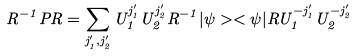Convert formula to latex. <formula><loc_0><loc_0><loc_500><loc_500>R ^ { - 1 } P R = \sum _ { j ^ { \prime } _ { 1 } , j ^ { \prime } _ { 2 } } U _ { 1 } ^ { j ^ { \prime } _ { 1 } } U _ { 2 } ^ { j ^ { \prime } _ { 2 } } R ^ { - 1 } | \psi > < \psi | R U _ { 1 } ^ { - j ^ { \prime } _ { 1 } } U _ { 2 } ^ { - j ^ { \prime } _ { 2 } }</formula> 